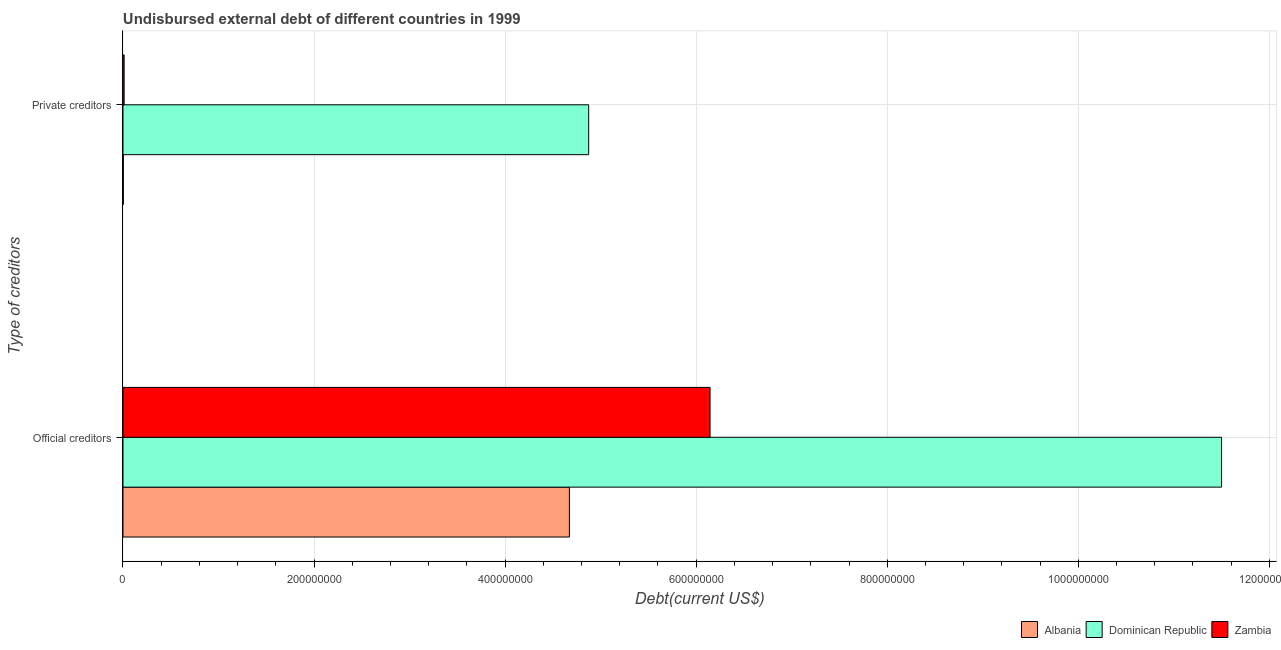Are the number of bars per tick equal to the number of legend labels?
Give a very brief answer. Yes. How many bars are there on the 2nd tick from the bottom?
Make the answer very short. 3. What is the label of the 1st group of bars from the top?
Provide a short and direct response. Private creditors. What is the undisbursed external debt of private creditors in Albania?
Your response must be concise. 3.67e+05. Across all countries, what is the maximum undisbursed external debt of private creditors?
Your response must be concise. 4.88e+08. Across all countries, what is the minimum undisbursed external debt of private creditors?
Make the answer very short. 3.67e+05. In which country was the undisbursed external debt of official creditors maximum?
Give a very brief answer. Dominican Republic. In which country was the undisbursed external debt of official creditors minimum?
Your answer should be very brief. Albania. What is the total undisbursed external debt of private creditors in the graph?
Make the answer very short. 4.89e+08. What is the difference between the undisbursed external debt of official creditors in Albania and that in Dominican Republic?
Ensure brevity in your answer.  -6.83e+08. What is the difference between the undisbursed external debt of private creditors in Zambia and the undisbursed external debt of official creditors in Albania?
Keep it short and to the point. -4.66e+08. What is the average undisbursed external debt of official creditors per country?
Provide a succinct answer. 7.44e+08. What is the difference between the undisbursed external debt of official creditors and undisbursed external debt of private creditors in Zambia?
Ensure brevity in your answer.  6.13e+08. What is the ratio of the undisbursed external debt of private creditors in Zambia to that in Dominican Republic?
Your answer should be compact. 0. In how many countries, is the undisbursed external debt of private creditors greater than the average undisbursed external debt of private creditors taken over all countries?
Keep it short and to the point. 1. What does the 2nd bar from the top in Private creditors represents?
Your response must be concise. Dominican Republic. What does the 1st bar from the bottom in Private creditors represents?
Provide a succinct answer. Albania. How many bars are there?
Offer a very short reply. 6. How many countries are there in the graph?
Your response must be concise. 3. What is the difference between two consecutive major ticks on the X-axis?
Provide a succinct answer. 2.00e+08. Are the values on the major ticks of X-axis written in scientific E-notation?
Your response must be concise. No. Does the graph contain any zero values?
Your answer should be very brief. No. Does the graph contain grids?
Offer a terse response. Yes. Where does the legend appear in the graph?
Provide a succinct answer. Bottom right. How many legend labels are there?
Your answer should be very brief. 3. How are the legend labels stacked?
Provide a succinct answer. Horizontal. What is the title of the graph?
Provide a succinct answer. Undisbursed external debt of different countries in 1999. What is the label or title of the X-axis?
Your answer should be very brief. Debt(current US$). What is the label or title of the Y-axis?
Provide a short and direct response. Type of creditors. What is the Debt(current US$) in Albania in Official creditors?
Your answer should be very brief. 4.67e+08. What is the Debt(current US$) in Dominican Republic in Official creditors?
Your response must be concise. 1.15e+09. What is the Debt(current US$) in Zambia in Official creditors?
Offer a very short reply. 6.15e+08. What is the Debt(current US$) of Albania in Private creditors?
Keep it short and to the point. 3.67e+05. What is the Debt(current US$) of Dominican Republic in Private creditors?
Ensure brevity in your answer.  4.88e+08. What is the Debt(current US$) in Zambia in Private creditors?
Your answer should be very brief. 1.21e+06. Across all Type of creditors, what is the maximum Debt(current US$) in Albania?
Ensure brevity in your answer.  4.67e+08. Across all Type of creditors, what is the maximum Debt(current US$) in Dominican Republic?
Your answer should be compact. 1.15e+09. Across all Type of creditors, what is the maximum Debt(current US$) in Zambia?
Offer a very short reply. 6.15e+08. Across all Type of creditors, what is the minimum Debt(current US$) in Albania?
Provide a succinct answer. 3.67e+05. Across all Type of creditors, what is the minimum Debt(current US$) in Dominican Republic?
Your response must be concise. 4.88e+08. Across all Type of creditors, what is the minimum Debt(current US$) in Zambia?
Offer a very short reply. 1.21e+06. What is the total Debt(current US$) of Albania in the graph?
Ensure brevity in your answer.  4.68e+08. What is the total Debt(current US$) of Dominican Republic in the graph?
Your answer should be compact. 1.64e+09. What is the total Debt(current US$) in Zambia in the graph?
Offer a terse response. 6.16e+08. What is the difference between the Debt(current US$) of Albania in Official creditors and that in Private creditors?
Provide a succinct answer. 4.67e+08. What is the difference between the Debt(current US$) of Dominican Republic in Official creditors and that in Private creditors?
Keep it short and to the point. 6.63e+08. What is the difference between the Debt(current US$) of Zambia in Official creditors and that in Private creditors?
Make the answer very short. 6.13e+08. What is the difference between the Debt(current US$) in Albania in Official creditors and the Debt(current US$) in Dominican Republic in Private creditors?
Ensure brevity in your answer.  -2.02e+07. What is the difference between the Debt(current US$) in Albania in Official creditors and the Debt(current US$) in Zambia in Private creditors?
Provide a short and direct response. 4.66e+08. What is the difference between the Debt(current US$) in Dominican Republic in Official creditors and the Debt(current US$) in Zambia in Private creditors?
Provide a short and direct response. 1.15e+09. What is the average Debt(current US$) of Albania per Type of creditors?
Your answer should be very brief. 2.34e+08. What is the average Debt(current US$) of Dominican Republic per Type of creditors?
Your answer should be very brief. 8.19e+08. What is the average Debt(current US$) of Zambia per Type of creditors?
Keep it short and to the point. 3.08e+08. What is the difference between the Debt(current US$) in Albania and Debt(current US$) in Dominican Republic in Official creditors?
Provide a short and direct response. -6.83e+08. What is the difference between the Debt(current US$) in Albania and Debt(current US$) in Zambia in Official creditors?
Your response must be concise. -1.47e+08. What is the difference between the Debt(current US$) in Dominican Republic and Debt(current US$) in Zambia in Official creditors?
Offer a very short reply. 5.35e+08. What is the difference between the Debt(current US$) of Albania and Debt(current US$) of Dominican Republic in Private creditors?
Provide a succinct answer. -4.87e+08. What is the difference between the Debt(current US$) of Albania and Debt(current US$) of Zambia in Private creditors?
Keep it short and to the point. -8.47e+05. What is the difference between the Debt(current US$) in Dominican Republic and Debt(current US$) in Zambia in Private creditors?
Keep it short and to the point. 4.86e+08. What is the ratio of the Debt(current US$) in Albania in Official creditors to that in Private creditors?
Provide a short and direct response. 1273.33. What is the ratio of the Debt(current US$) of Dominican Republic in Official creditors to that in Private creditors?
Ensure brevity in your answer.  2.36. What is the ratio of the Debt(current US$) of Zambia in Official creditors to that in Private creditors?
Ensure brevity in your answer.  506.23. What is the difference between the highest and the second highest Debt(current US$) of Albania?
Provide a succinct answer. 4.67e+08. What is the difference between the highest and the second highest Debt(current US$) of Dominican Republic?
Provide a short and direct response. 6.63e+08. What is the difference between the highest and the second highest Debt(current US$) in Zambia?
Keep it short and to the point. 6.13e+08. What is the difference between the highest and the lowest Debt(current US$) of Albania?
Your response must be concise. 4.67e+08. What is the difference between the highest and the lowest Debt(current US$) in Dominican Republic?
Provide a succinct answer. 6.63e+08. What is the difference between the highest and the lowest Debt(current US$) in Zambia?
Keep it short and to the point. 6.13e+08. 